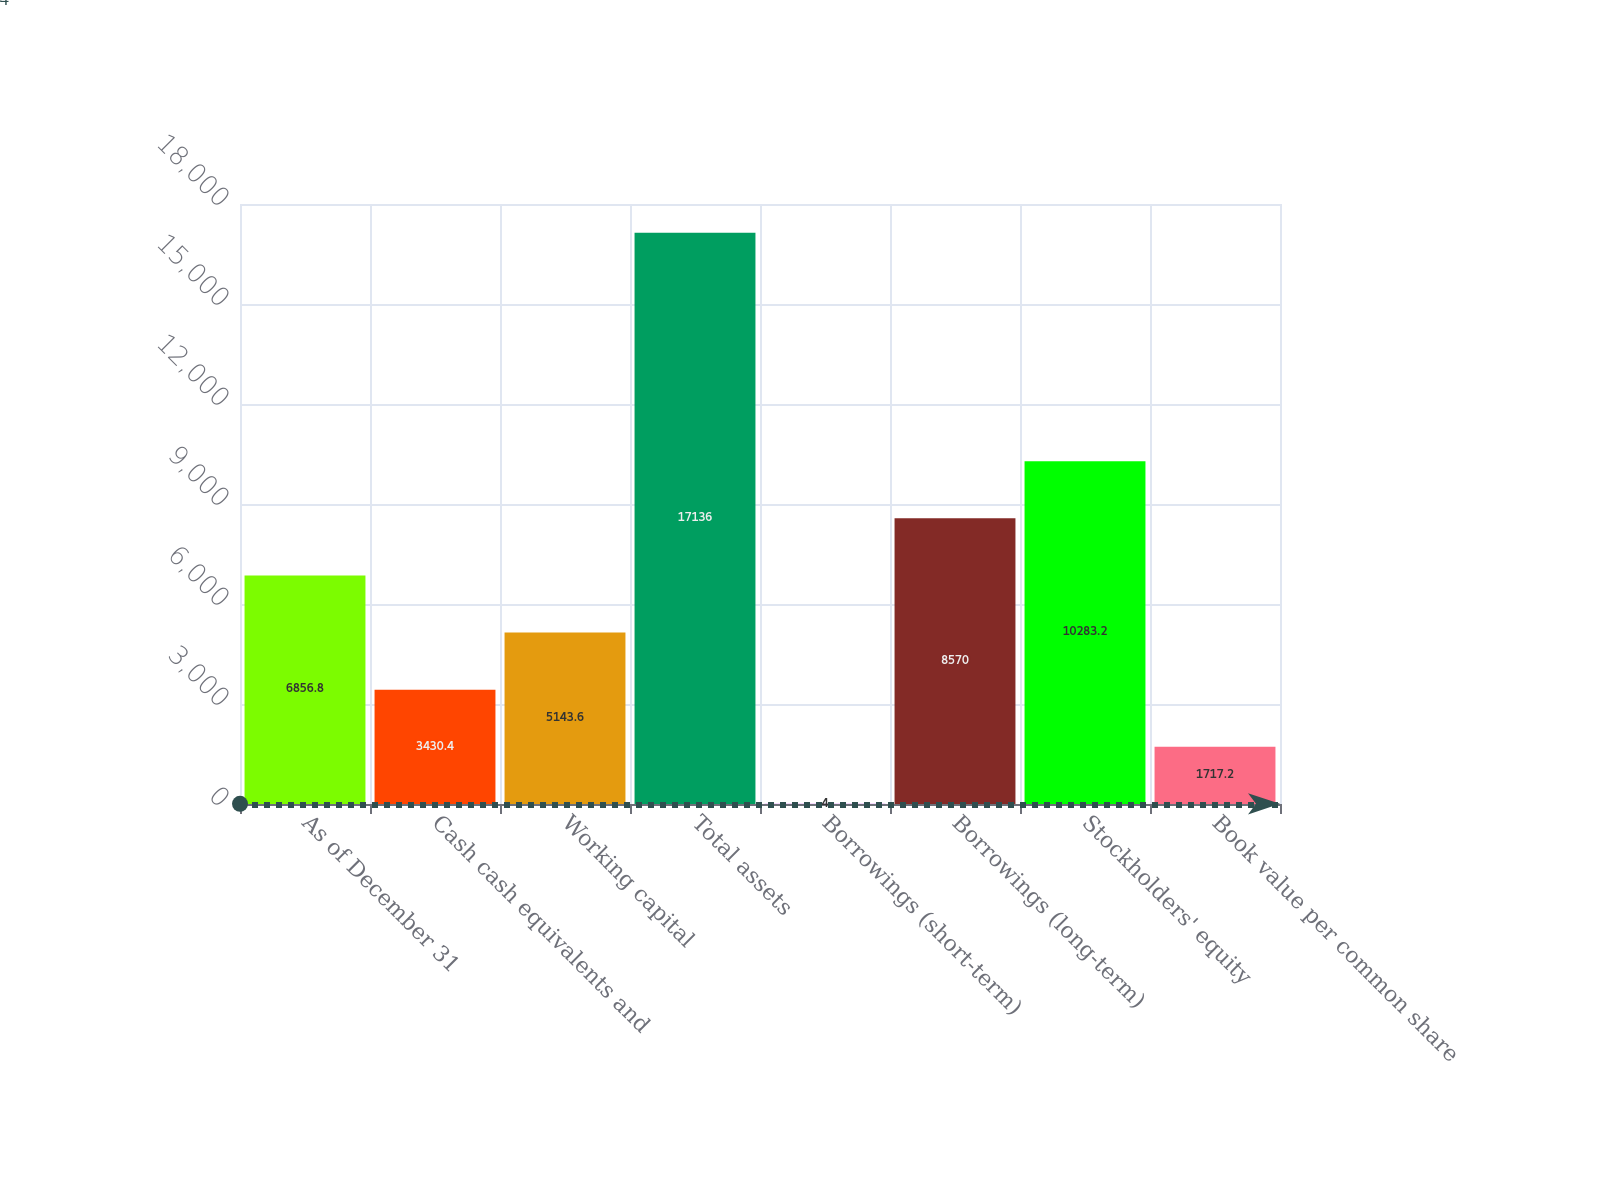Convert chart. <chart><loc_0><loc_0><loc_500><loc_500><bar_chart><fcel>As of December 31<fcel>Cash cash equivalents and<fcel>Working capital<fcel>Total assets<fcel>Borrowings (short-term)<fcel>Borrowings (long-term)<fcel>Stockholders' equity<fcel>Book value per common share<nl><fcel>6856.8<fcel>3430.4<fcel>5143.6<fcel>17136<fcel>4<fcel>8570<fcel>10283.2<fcel>1717.2<nl></chart> 